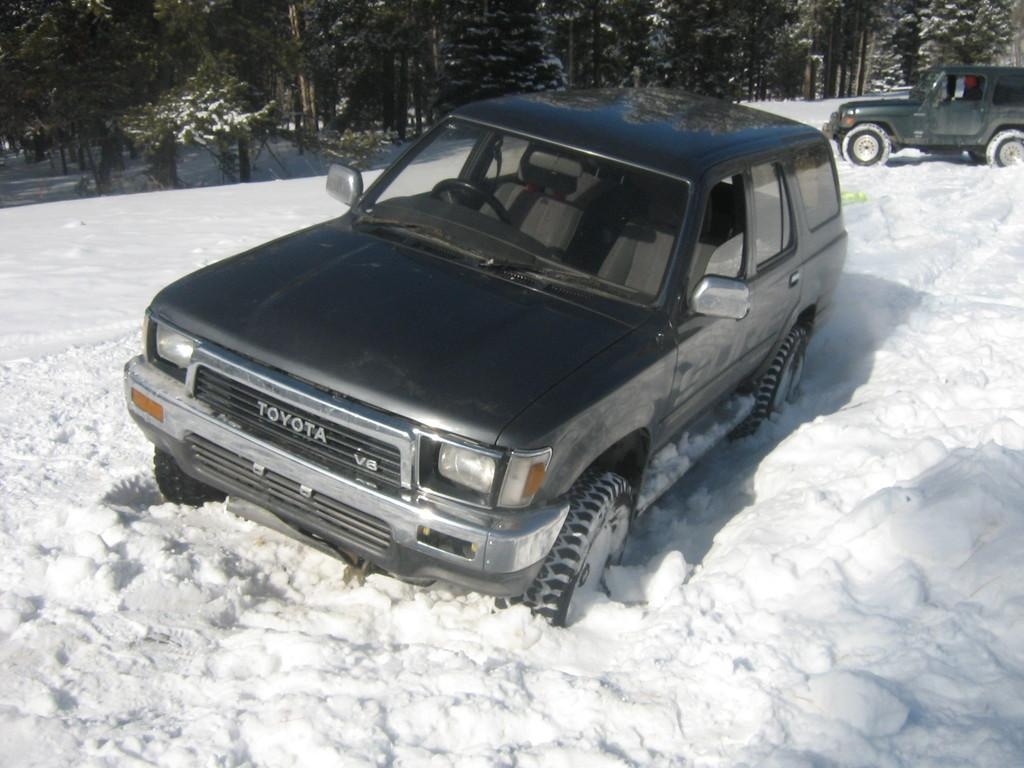What can be seen in the image? There are vehicles in the image. What is the condition of the land in the image? The land is covered with snow. What can be seen in the background of the image? There are trees in the background of the image. What type of hair can be seen on the vehicles in the image? There is no hair present on the vehicles in the image. What kind of cheese is being used to decorate the trees in the background? There is no cheese present in the image, and the trees are not decorated. 